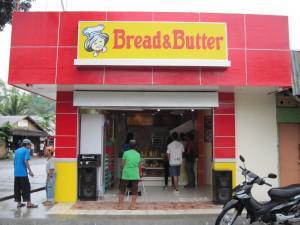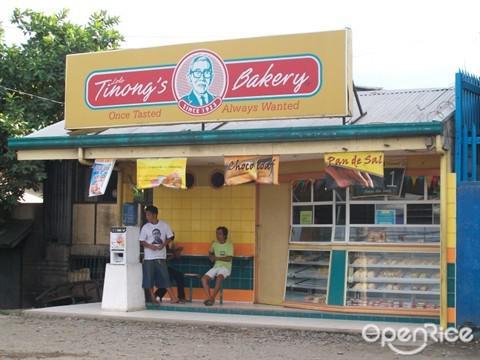The first image is the image on the left, the second image is the image on the right. Assess this claim about the two images: "The right image shows an open-front shop with a yellow sign featuring a cartoon chef face on a red facade, and red and yellow balloons reaching as high as the doorway.". Correct or not? Answer yes or no. No. 